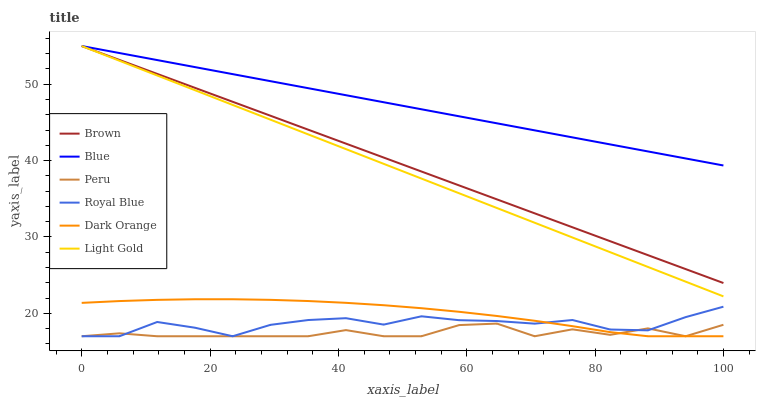Does Peru have the minimum area under the curve?
Answer yes or no. Yes. Does Blue have the maximum area under the curve?
Answer yes or no. Yes. Does Brown have the minimum area under the curve?
Answer yes or no. No. Does Brown have the maximum area under the curve?
Answer yes or no. No. Is Light Gold the smoothest?
Answer yes or no. Yes. Is Royal Blue the roughest?
Answer yes or no. Yes. Is Brown the smoothest?
Answer yes or no. No. Is Brown the roughest?
Answer yes or no. No. Does Dark Orange have the lowest value?
Answer yes or no. Yes. Does Brown have the lowest value?
Answer yes or no. No. Does Light Gold have the highest value?
Answer yes or no. Yes. Does Dark Orange have the highest value?
Answer yes or no. No. Is Peru less than Light Gold?
Answer yes or no. Yes. Is Light Gold greater than Royal Blue?
Answer yes or no. Yes. Does Royal Blue intersect Dark Orange?
Answer yes or no. Yes. Is Royal Blue less than Dark Orange?
Answer yes or no. No. Is Royal Blue greater than Dark Orange?
Answer yes or no. No. Does Peru intersect Light Gold?
Answer yes or no. No. 